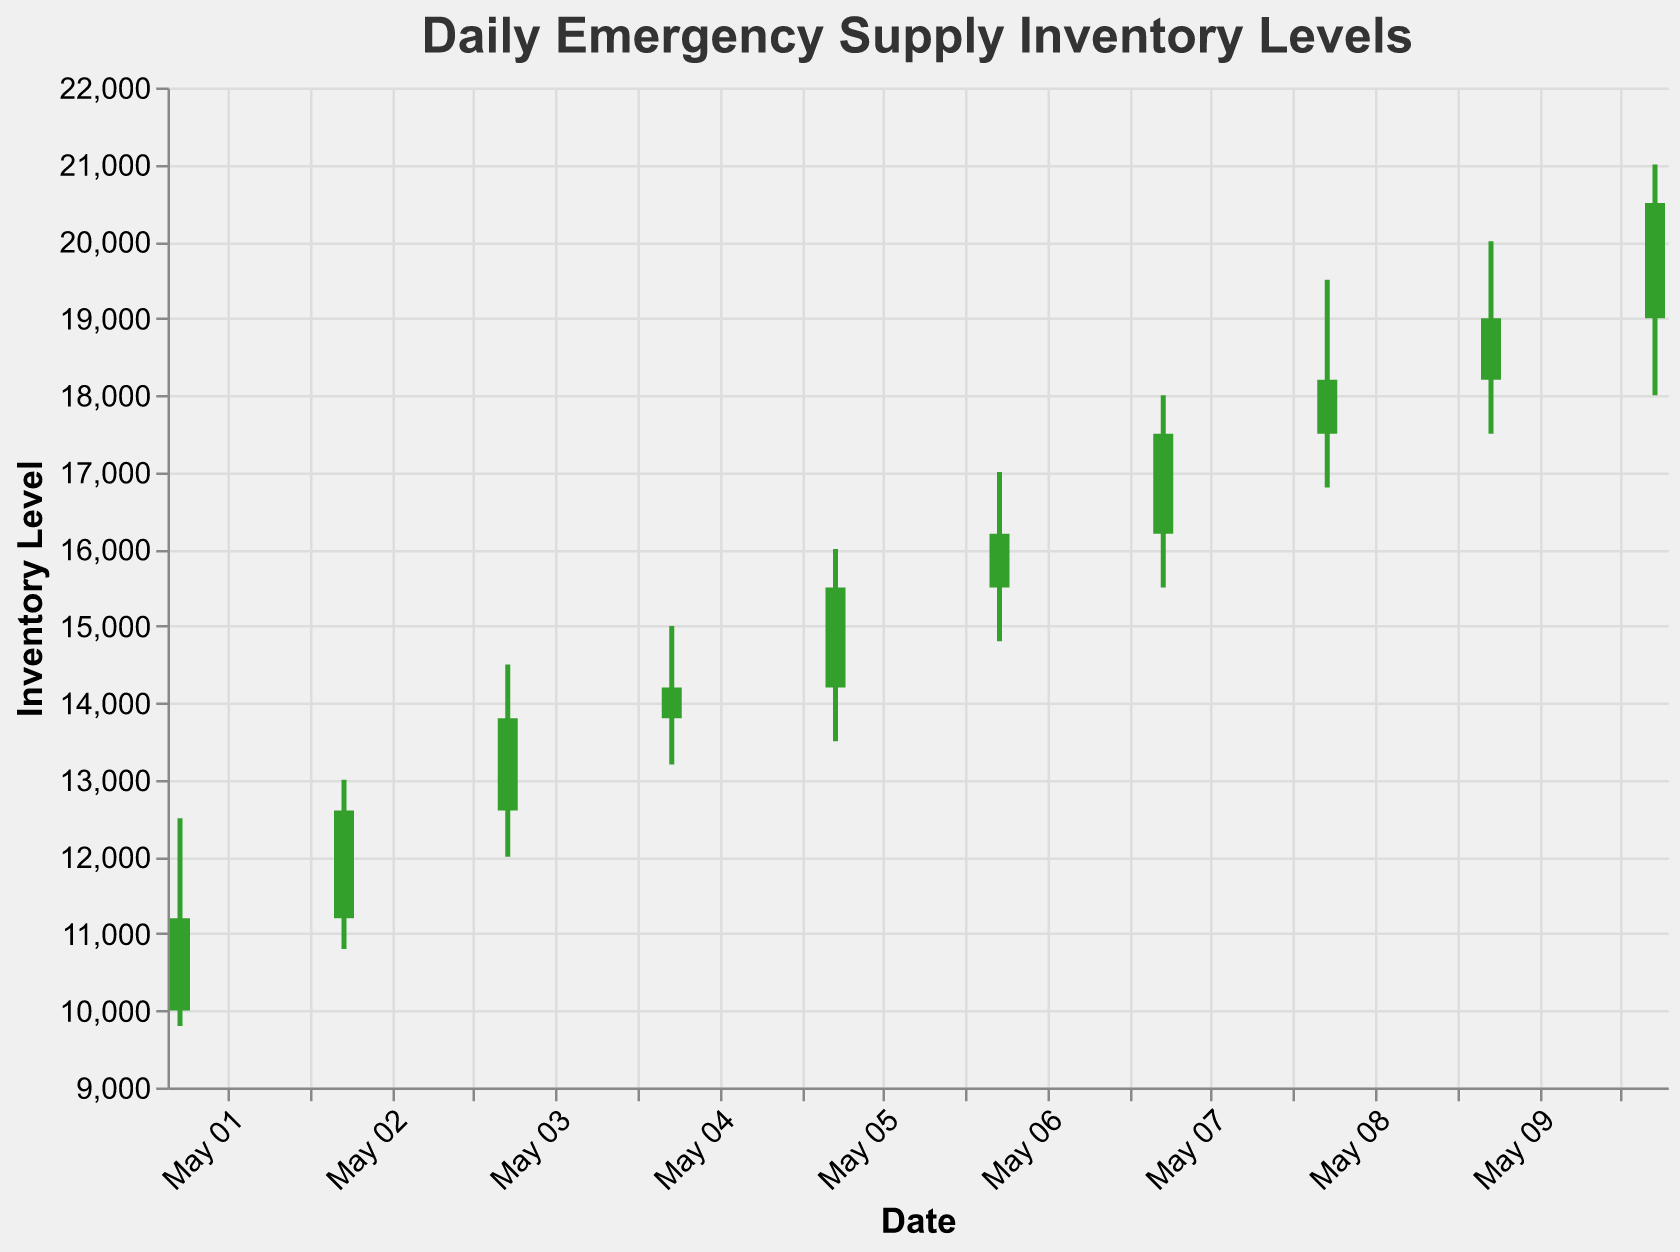What is the title of the figure? The title of the figure is usually found at the top of the chart and provides a summary of what the figure represents. In this case, it reads "Daily Emergency Supply Inventory Levels".
Answer: Daily Emergency Supply Inventory Levels What is the highest inventory level observed during this period? Examine the "High" values in the dataset. The highest value, 21000, is found on the date 2023-05-10.
Answer: 21000 What color represents a day when the inventory level increased? According to the color condition in the figure, green (#33a02c) represents days when the Close value is higher than the Open value, indicating an increase.
Answer: Green On which date did the emergency supply inventory close at its lowest level? Look for the lowest "Close" value in the dataset, which is 11200 on the date 2023-05-01.
Answer: 2023-05-01 What is the range of the inventory level on 2023-05-05? The range is the difference between the "High" and "Low" values for that date. For 2023-05-05, the "High" is 16000, and the "Low" is 13500, so the range is 16000 - 13500 = 2500.
Answer: 2500 Which day had the largest increase in inventory level from Open to Close? Find the difference between "Close" and "Open" for each date. The largest increase is from 19000 to 20500 on 2023-05-10, which is an increase of 1500.
Answer: 2023-05-10 How many days show a decline in the inventory level by the end of the day? A decline is indicated if the "Close" value is less than the "Open" value and is represented by a red color in the chart. By examining the dataset, there are no days with a decline.
Answer: 0 What is the average opening inventory level during this period? Sum the "Open" values and divide by the number of days. The sum of Open values is 10000 + 11200 + 12600 + 13800 + 14200 + 15500 + 16200 + 17500 + 18200 + 19000 = 148200. The average is 148200 / 10 = 14820.
Answer: 14820 Compare the closing levels of the first and last days. How much did the inventory level increase? The "Close" value for the first day (2023-05-01) is 11200, and for the last day (2023-05-10) it is 20500. The increase is 20500 - 11200 = 9300.
Answer: 9300 